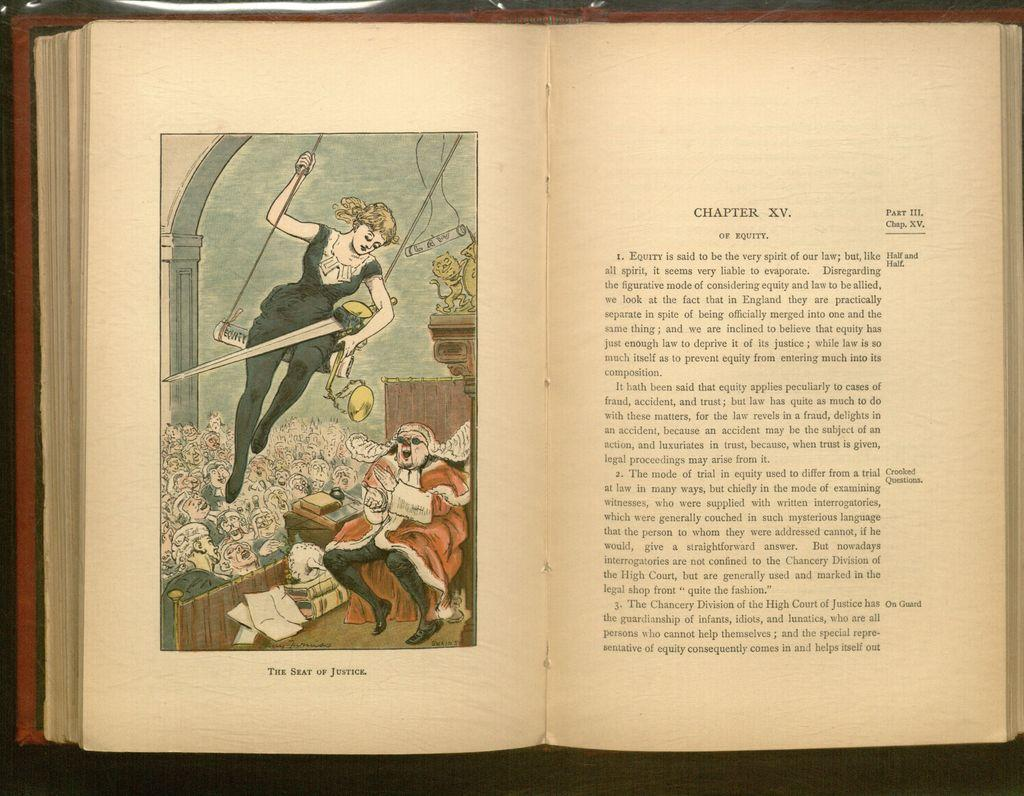<image>
Share a concise interpretation of the image provided. Bok open to page that has picture titled The Seat of Justice. 